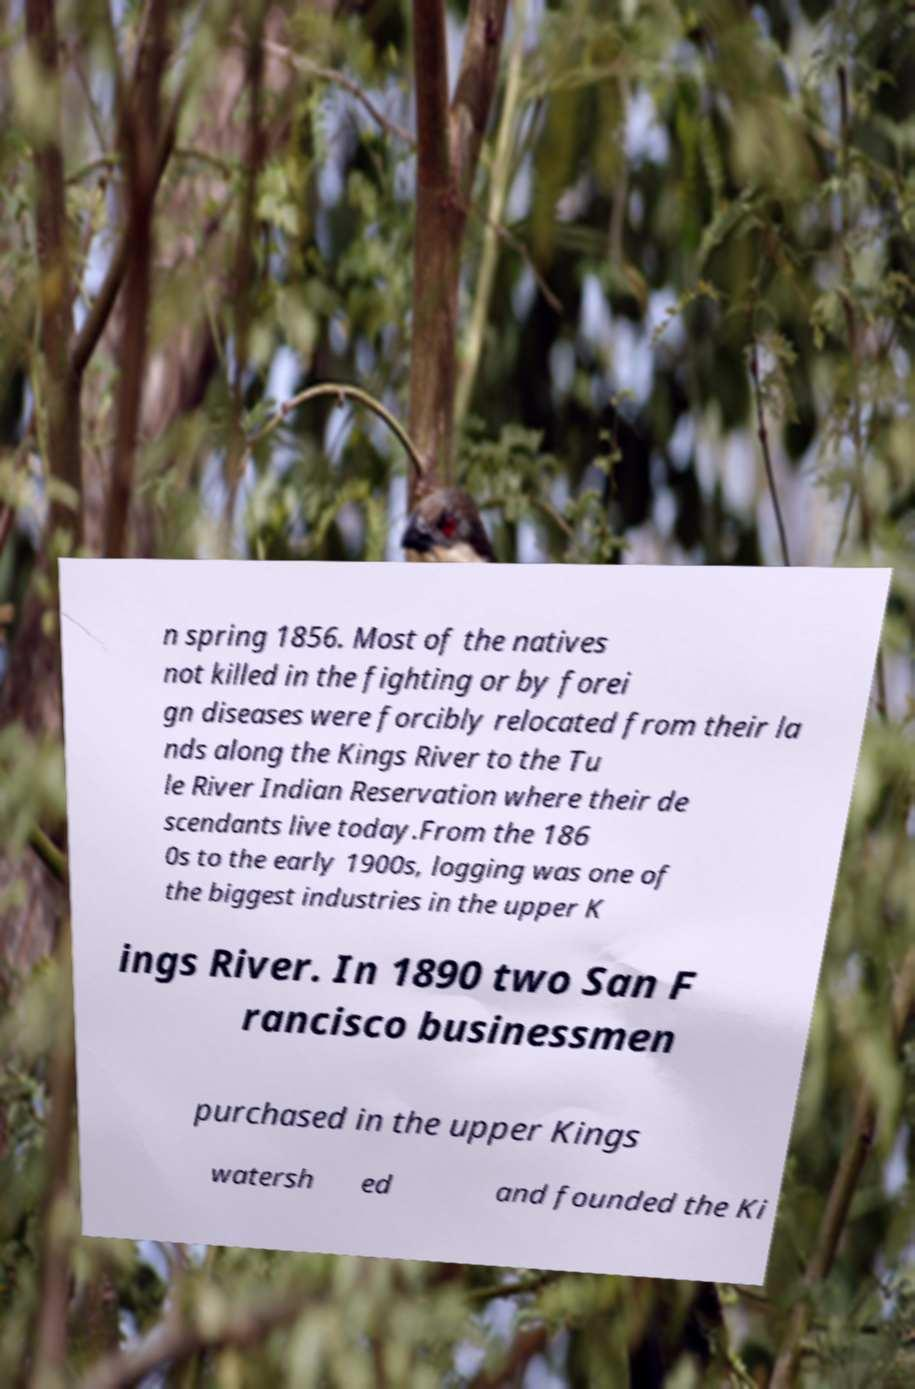Could you assist in decoding the text presented in this image and type it out clearly? n spring 1856. Most of the natives not killed in the fighting or by forei gn diseases were forcibly relocated from their la nds along the Kings River to the Tu le River Indian Reservation where their de scendants live today.From the 186 0s to the early 1900s, logging was one of the biggest industries in the upper K ings River. In 1890 two San F rancisco businessmen purchased in the upper Kings watersh ed and founded the Ki 